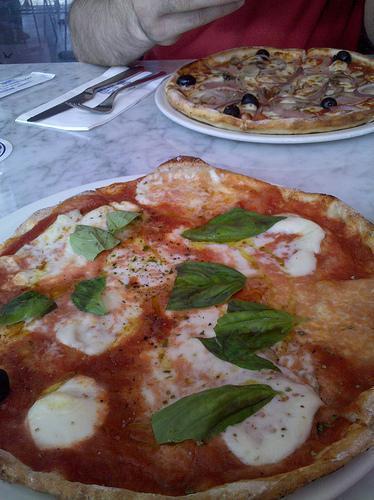How many pizzas are on the table?
Give a very brief answer. 2. 